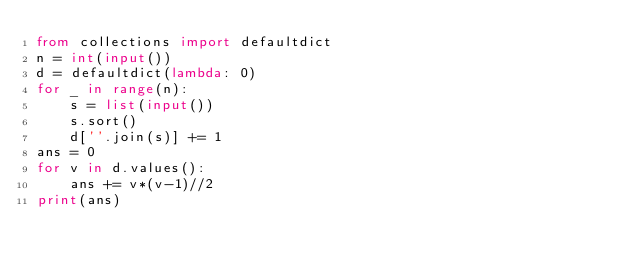Convert code to text. <code><loc_0><loc_0><loc_500><loc_500><_Python_>from collections import defaultdict
n = int(input())
d = defaultdict(lambda: 0)
for _ in range(n):
    s = list(input())
    s.sort()
    d[''.join(s)] += 1
ans = 0
for v in d.values():
    ans += v*(v-1)//2
print(ans)
</code> 